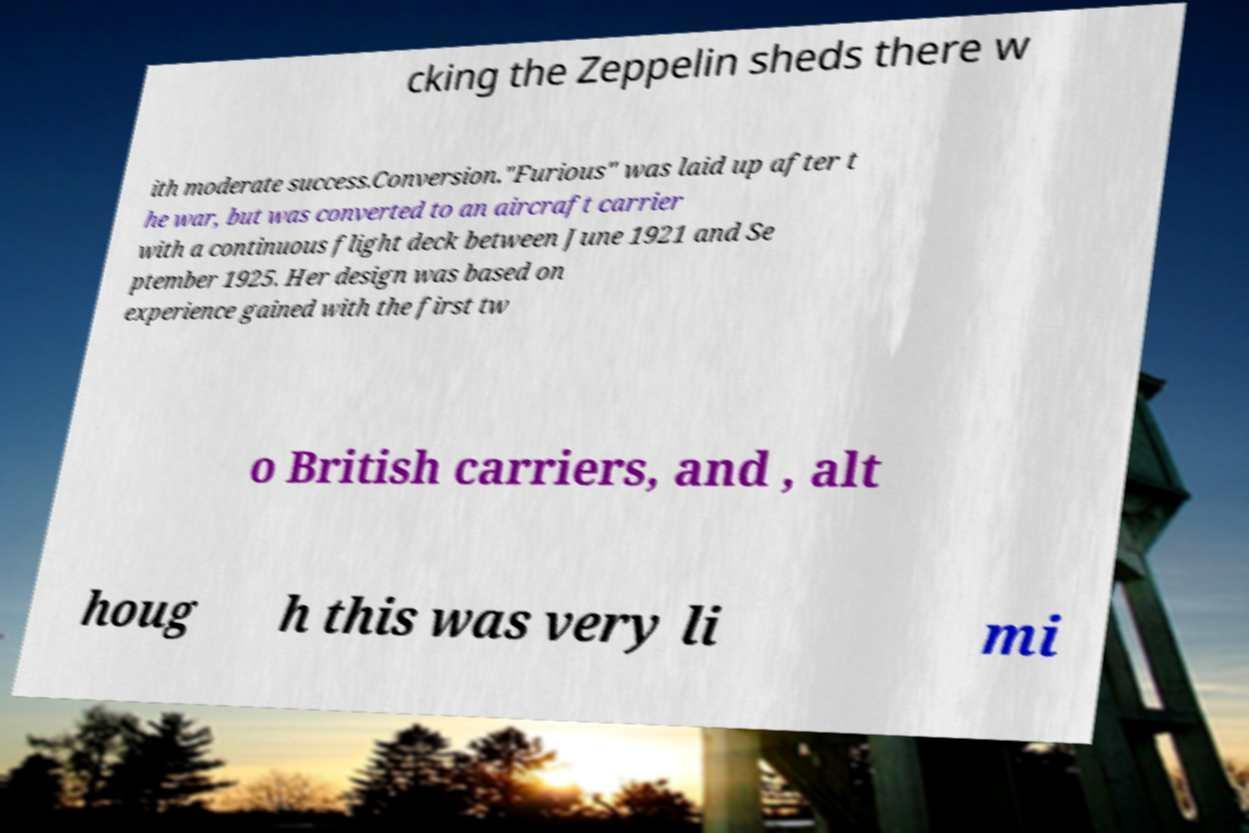There's text embedded in this image that I need extracted. Can you transcribe it verbatim? cking the Zeppelin sheds there w ith moderate success.Conversion."Furious" was laid up after t he war, but was converted to an aircraft carrier with a continuous flight deck between June 1921 and Se ptember 1925. Her design was based on experience gained with the first tw o British carriers, and , alt houg h this was very li mi 